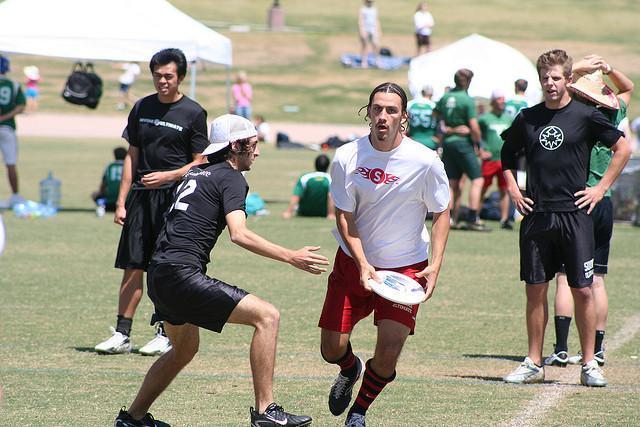How many of these Frisbee players are wearing hats?
Give a very brief answer. 2. How many people are visible?
Give a very brief answer. 10. How many glasses are full of orange juice?
Give a very brief answer. 0. 